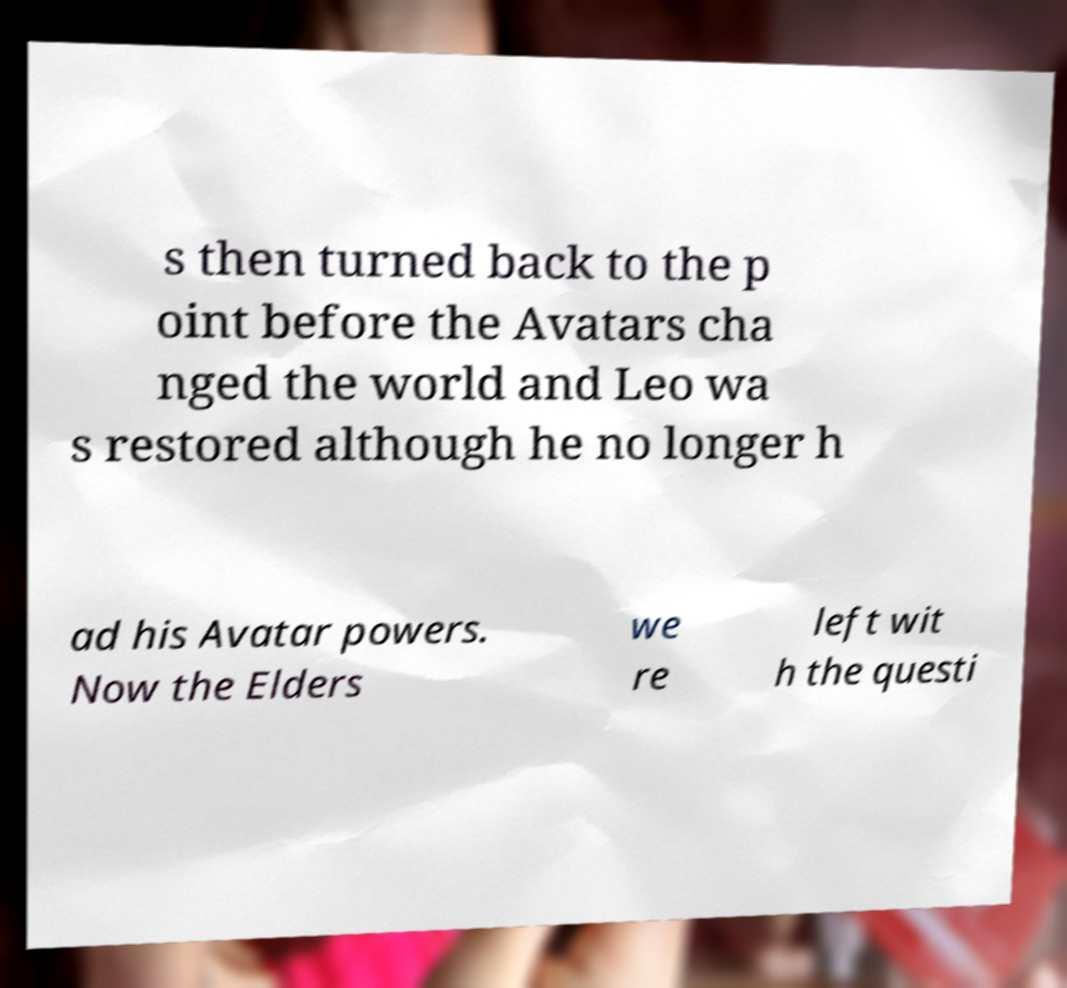Could you assist in decoding the text presented in this image and type it out clearly? s then turned back to the p oint before the Avatars cha nged the world and Leo wa s restored although he no longer h ad his Avatar powers. Now the Elders we re left wit h the questi 